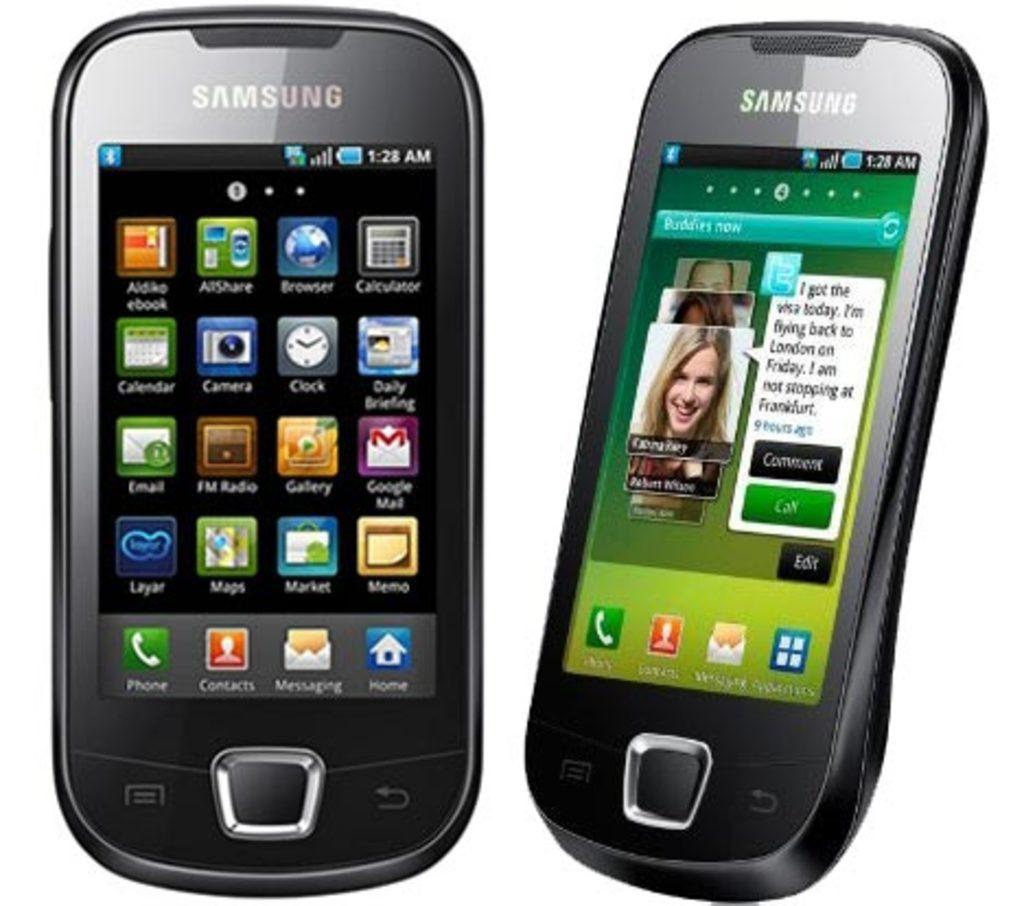<image>
Give a short and clear explanation of the subsequent image. a samsung phone that shows the phone app on the screen 